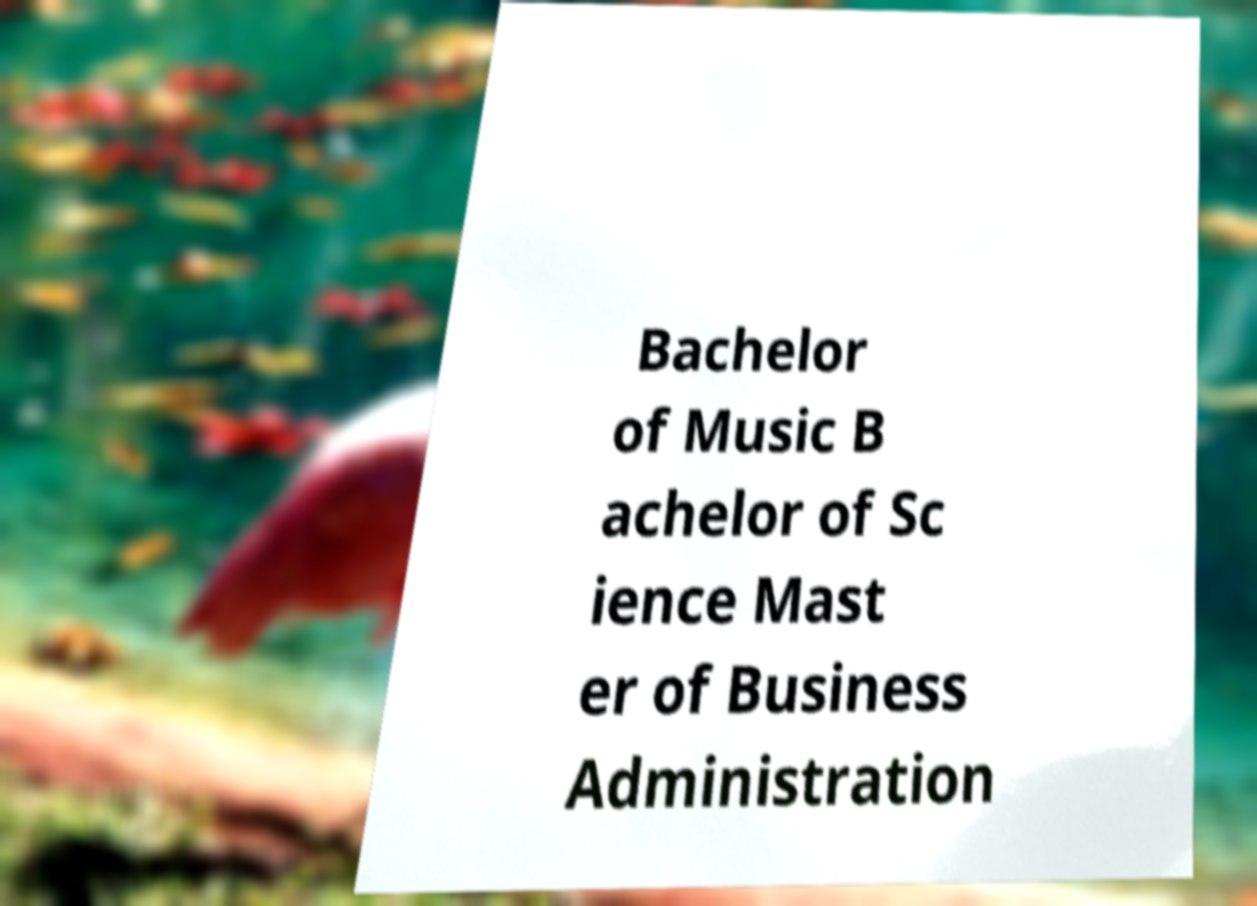Please identify and transcribe the text found in this image. Bachelor of Music B achelor of Sc ience Mast er of Business Administration 